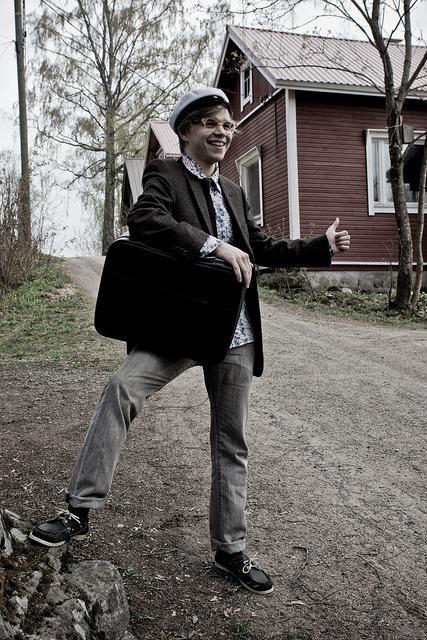How many cupcakes have an elephant on them?
Give a very brief answer. 0. 